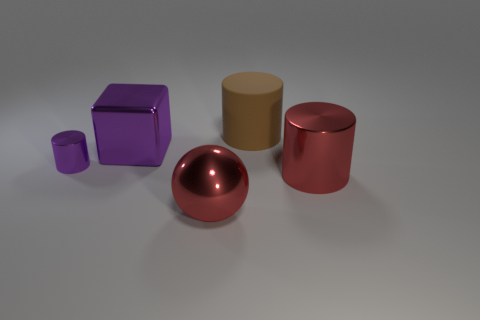Add 1 small matte cylinders. How many objects exist? 6 Subtract all blocks. How many objects are left? 4 Add 1 brown matte cylinders. How many brown matte cylinders are left? 2 Add 4 tiny purple cylinders. How many tiny purple cylinders exist? 5 Subtract 0 green cubes. How many objects are left? 5 Subtract all tiny purple metallic cylinders. Subtract all large brown metallic objects. How many objects are left? 4 